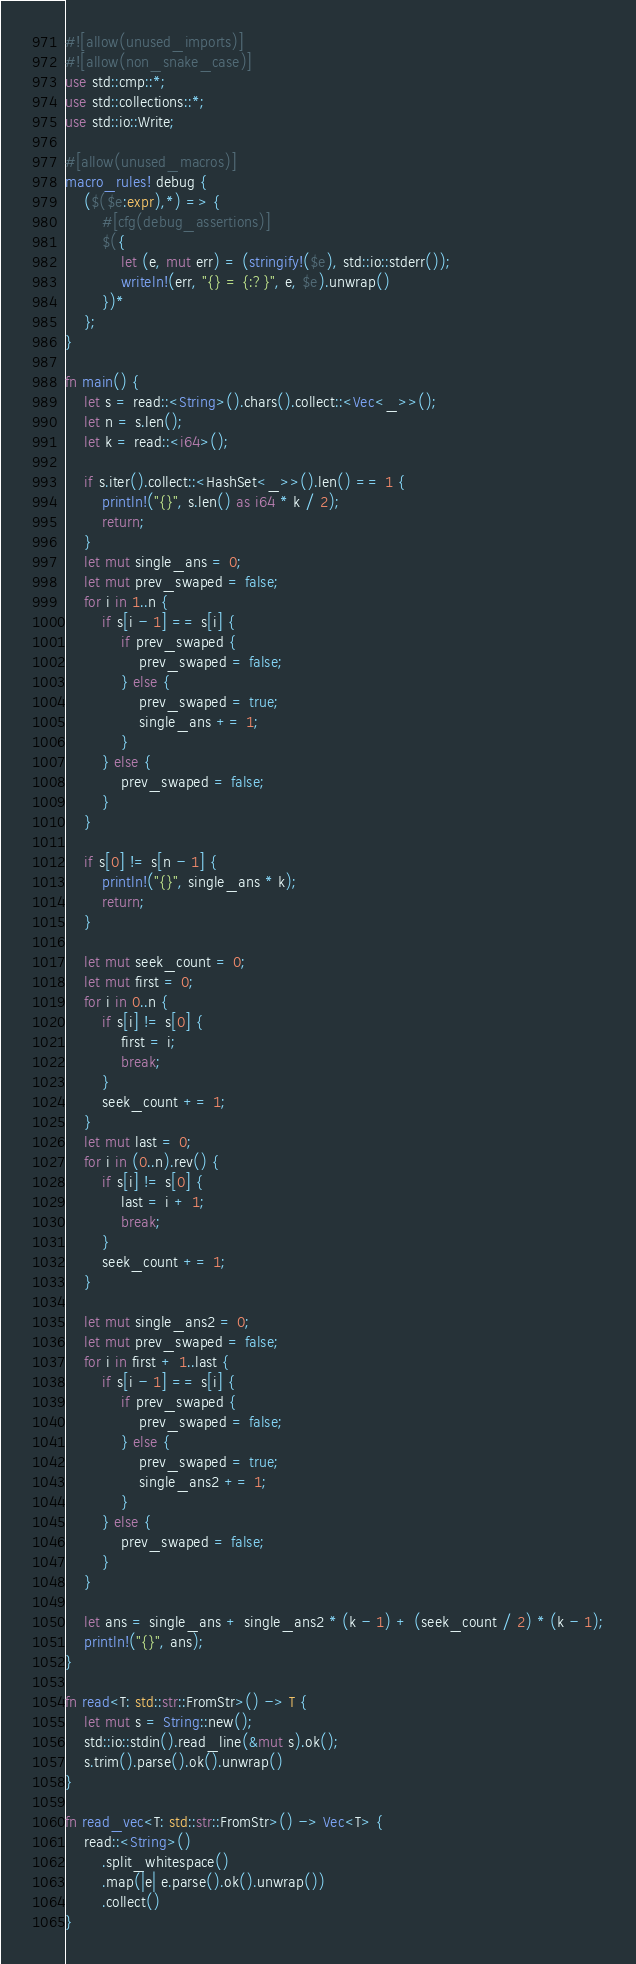Convert code to text. <code><loc_0><loc_0><loc_500><loc_500><_Rust_>#![allow(unused_imports)]
#![allow(non_snake_case)]
use std::cmp::*;
use std::collections::*;
use std::io::Write;

#[allow(unused_macros)]
macro_rules! debug {
    ($($e:expr),*) => {
        #[cfg(debug_assertions)]
        $({
            let (e, mut err) = (stringify!($e), std::io::stderr());
            writeln!(err, "{} = {:?}", e, $e).unwrap()
        })*
    };
}

fn main() {
    let s = read::<String>().chars().collect::<Vec<_>>();
    let n = s.len();
    let k = read::<i64>();

    if s.iter().collect::<HashSet<_>>().len() == 1 {
        println!("{}", s.len() as i64 * k / 2);
        return;
    }
    let mut single_ans = 0;
    let mut prev_swaped = false;
    for i in 1..n {
        if s[i - 1] == s[i] {
            if prev_swaped {
                prev_swaped = false;
            } else {
                prev_swaped = true;
                single_ans += 1;
            }
        } else {
            prev_swaped = false;
        }
    }

    if s[0] != s[n - 1] {
        println!("{}", single_ans * k);
        return;
    }

    let mut seek_count = 0;
    let mut first = 0;
    for i in 0..n {
        if s[i] != s[0] {
            first = i;
            break;
        }
        seek_count += 1;
    }
    let mut last = 0;
    for i in (0..n).rev() {
        if s[i] != s[0] {
            last = i + 1;
            break;
        }
        seek_count += 1;
    }

    let mut single_ans2 = 0;
    let mut prev_swaped = false;
    for i in first + 1..last {
        if s[i - 1] == s[i] {
            if prev_swaped {
                prev_swaped = false;
            } else {
                prev_swaped = true;
                single_ans2 += 1;
            }
        } else {
            prev_swaped = false;
        }
    }

    let ans = single_ans + single_ans2 * (k - 1) + (seek_count / 2) * (k - 1);
    println!("{}", ans);
}

fn read<T: std::str::FromStr>() -> T {
    let mut s = String::new();
    std::io::stdin().read_line(&mut s).ok();
    s.trim().parse().ok().unwrap()
}

fn read_vec<T: std::str::FromStr>() -> Vec<T> {
    read::<String>()
        .split_whitespace()
        .map(|e| e.parse().ok().unwrap())
        .collect()
}
</code> 